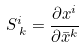Convert formula to latex. <formula><loc_0><loc_0><loc_500><loc_500>S ^ { i } _ { \, k } = \frac { \partial x ^ { i } } { \partial \bar { x } ^ { k } }</formula> 